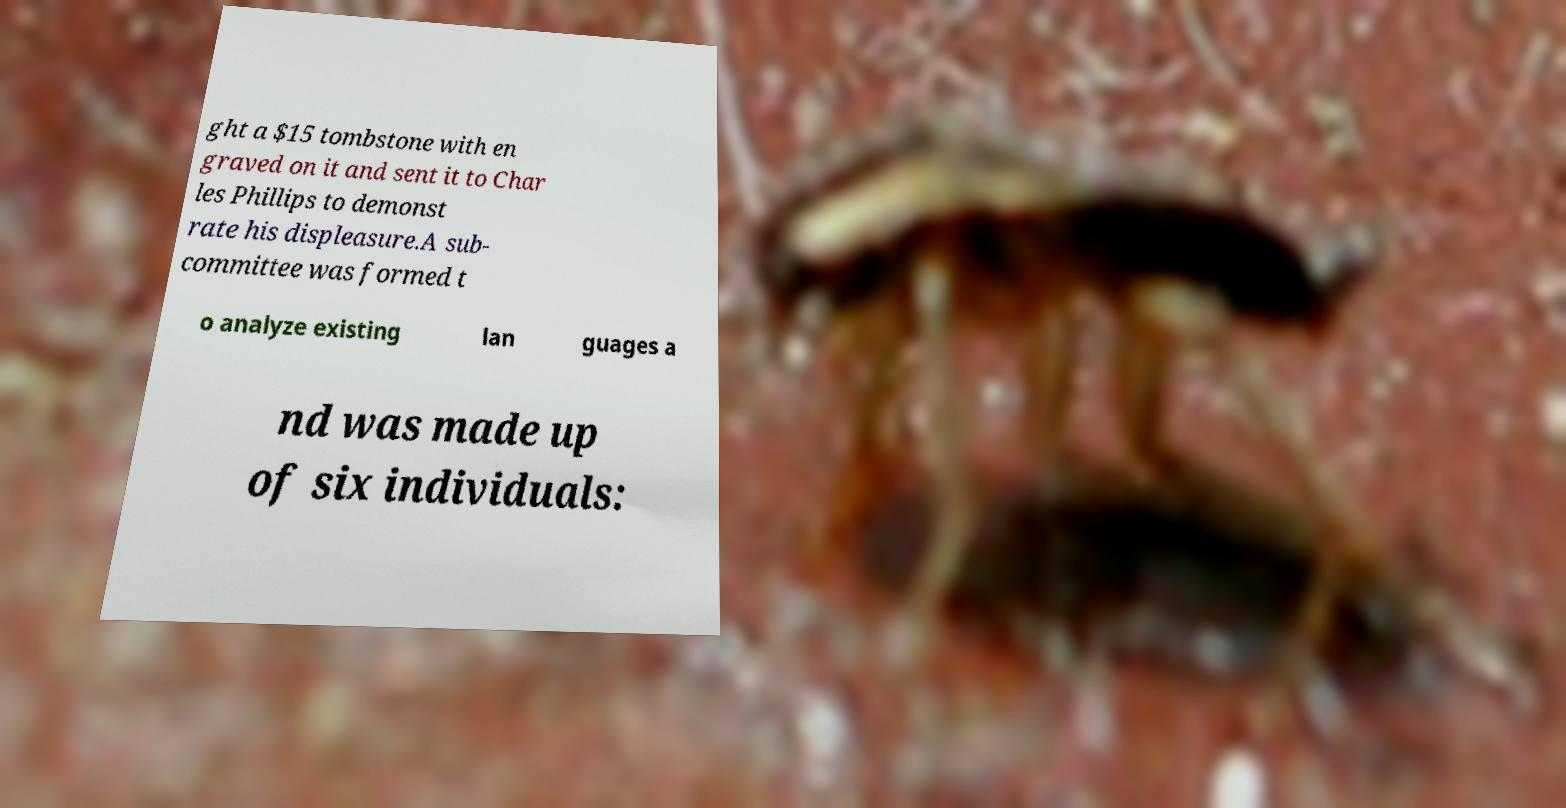Could you extract and type out the text from this image? ght a $15 tombstone with en graved on it and sent it to Char les Phillips to demonst rate his displeasure.A sub- committee was formed t o analyze existing lan guages a nd was made up of six individuals: 